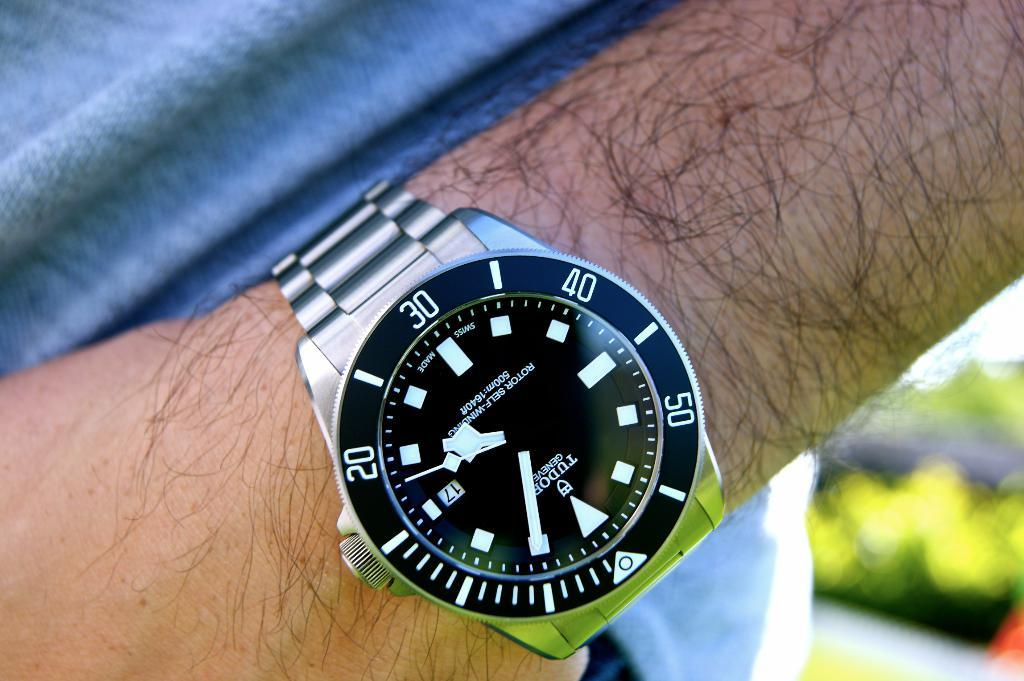<image>
Share a concise interpretation of the image provided. A man is wearing a wristwatch which has the number 30 at the top . 